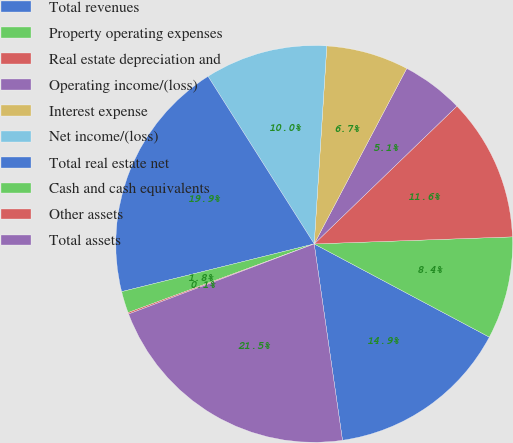Convert chart to OTSL. <chart><loc_0><loc_0><loc_500><loc_500><pie_chart><fcel>Total revenues<fcel>Property operating expenses<fcel>Real estate depreciation and<fcel>Operating income/(loss)<fcel>Interest expense<fcel>Net income/(loss)<fcel>Total real estate net<fcel>Cash and cash equivalents<fcel>Other assets<fcel>Total assets<nl><fcel>14.94%<fcel>8.35%<fcel>11.65%<fcel>5.06%<fcel>6.71%<fcel>10.0%<fcel>19.88%<fcel>1.76%<fcel>0.12%<fcel>21.53%<nl></chart> 